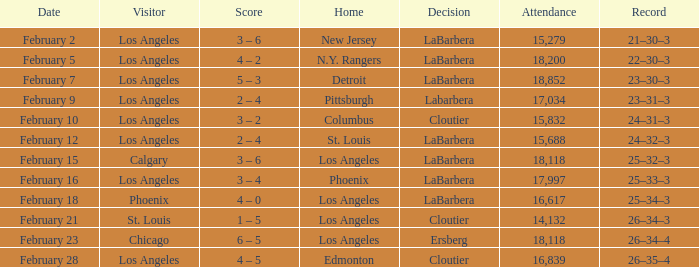What was the decision of the Kings game when Chicago was the visiting team? Ersberg. 